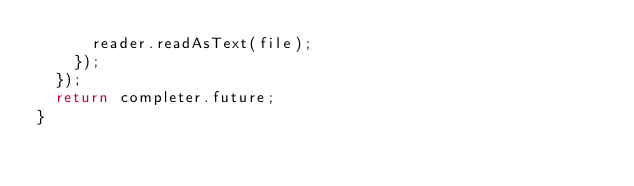Convert code to text. <code><loc_0><loc_0><loc_500><loc_500><_Dart_>      reader.readAsText(file);
    });
  });
  return completer.future;
}
</code> 